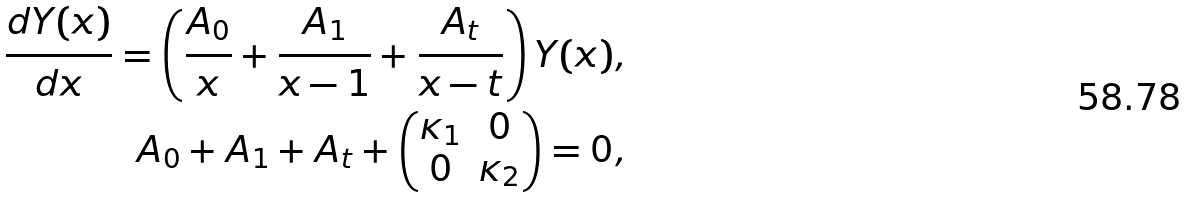Convert formula to latex. <formula><loc_0><loc_0><loc_500><loc_500>\frac { d Y ( x ) } { d x } = \left ( \frac { A _ { 0 } } { x } + \frac { A _ { 1 } } { x - 1 } + \frac { A _ { t } } { x - t } \right ) Y ( x ) , \\ A _ { 0 } + A _ { 1 } + A _ { t } + \begin{pmatrix} \kappa _ { 1 } & 0 \\ 0 & \kappa _ { 2 } \end{pmatrix} = 0 ,</formula> 